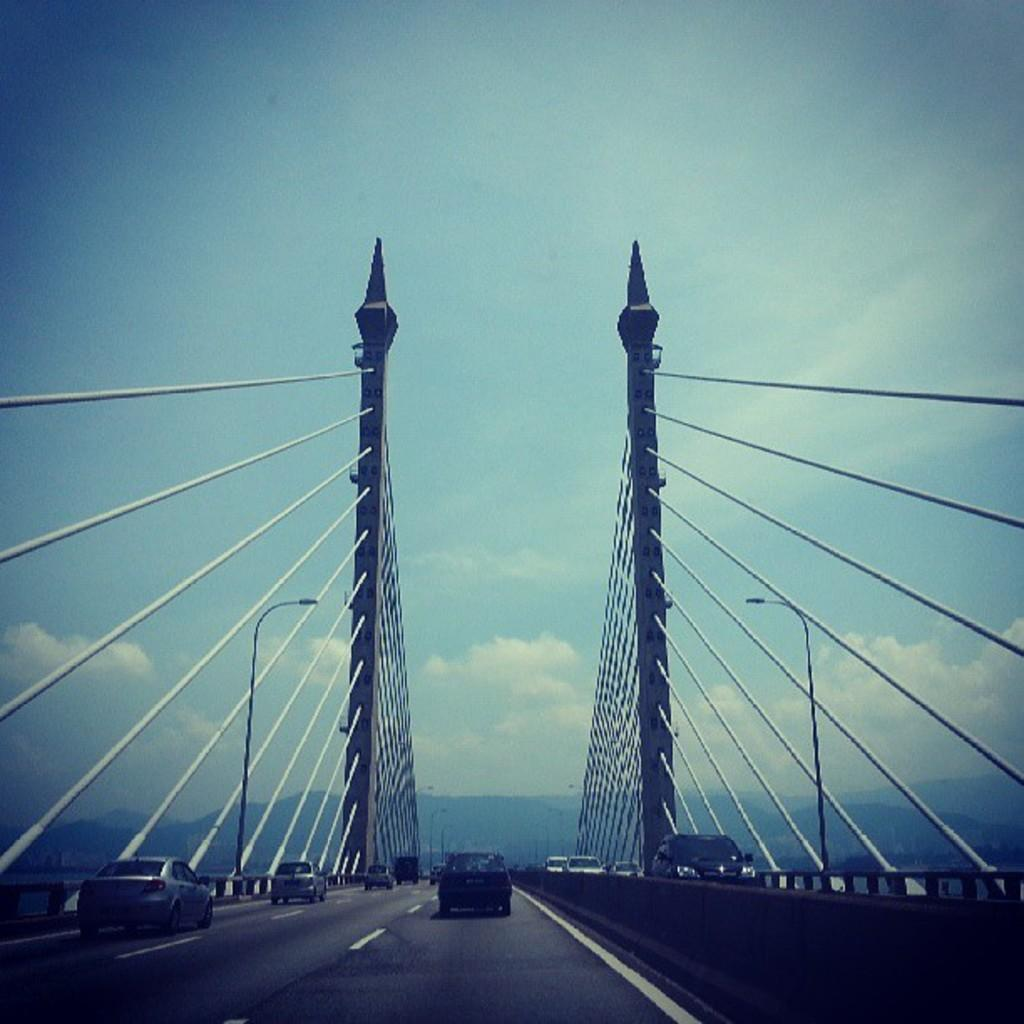What structures are present in the image? There are poles in the image. What is happening at the bottom of the image? There are vehicles on the road at the bottom of the image. What can be seen in the background of the image? The sky and mountains are visible in the background of the image. What color is the mark on the carriage in the image? There is no carriage or mark present in the image. 